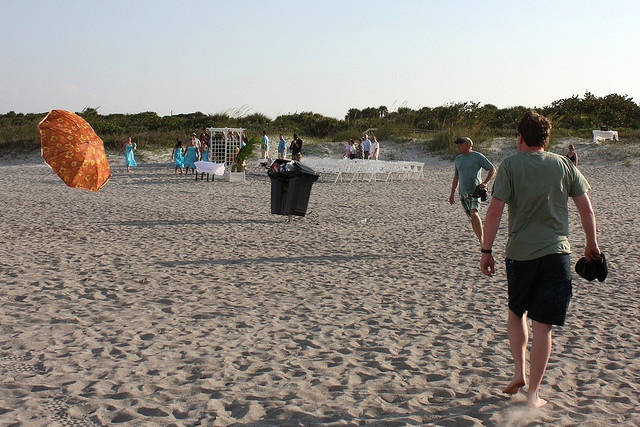Describe the objects in this image and their specific colors. I can see people in lightgray, black, gray, and maroon tones, umbrella in lightgray, brown, maroon, and orange tones, people in lightgray, black, gray, darkgray, and darkgreen tones, people in lightgray, black, purple, maroon, and gray tones, and chair in lightgray, darkgray, and gray tones in this image. 